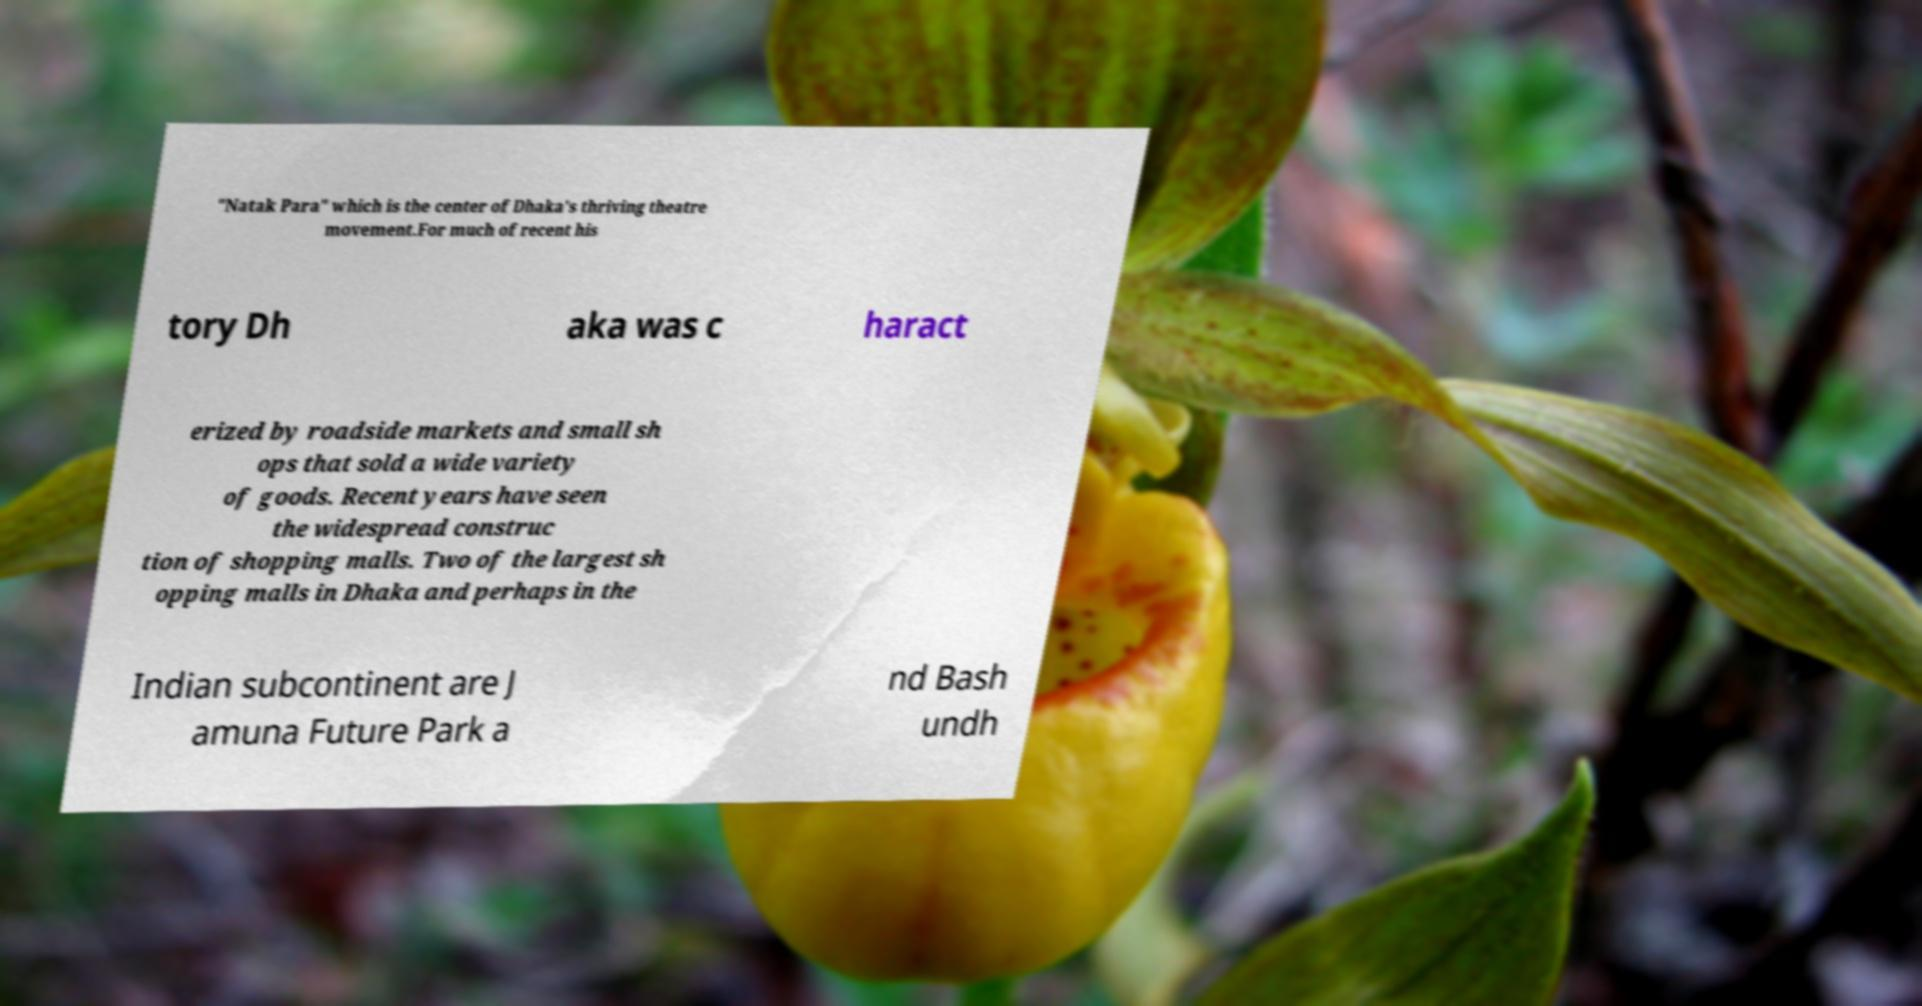Can you accurately transcribe the text from the provided image for me? "Natak Para" which is the center of Dhaka's thriving theatre movement.For much of recent his tory Dh aka was c haract erized by roadside markets and small sh ops that sold a wide variety of goods. Recent years have seen the widespread construc tion of shopping malls. Two of the largest sh opping malls in Dhaka and perhaps in the Indian subcontinent are J amuna Future Park a nd Bash undh 